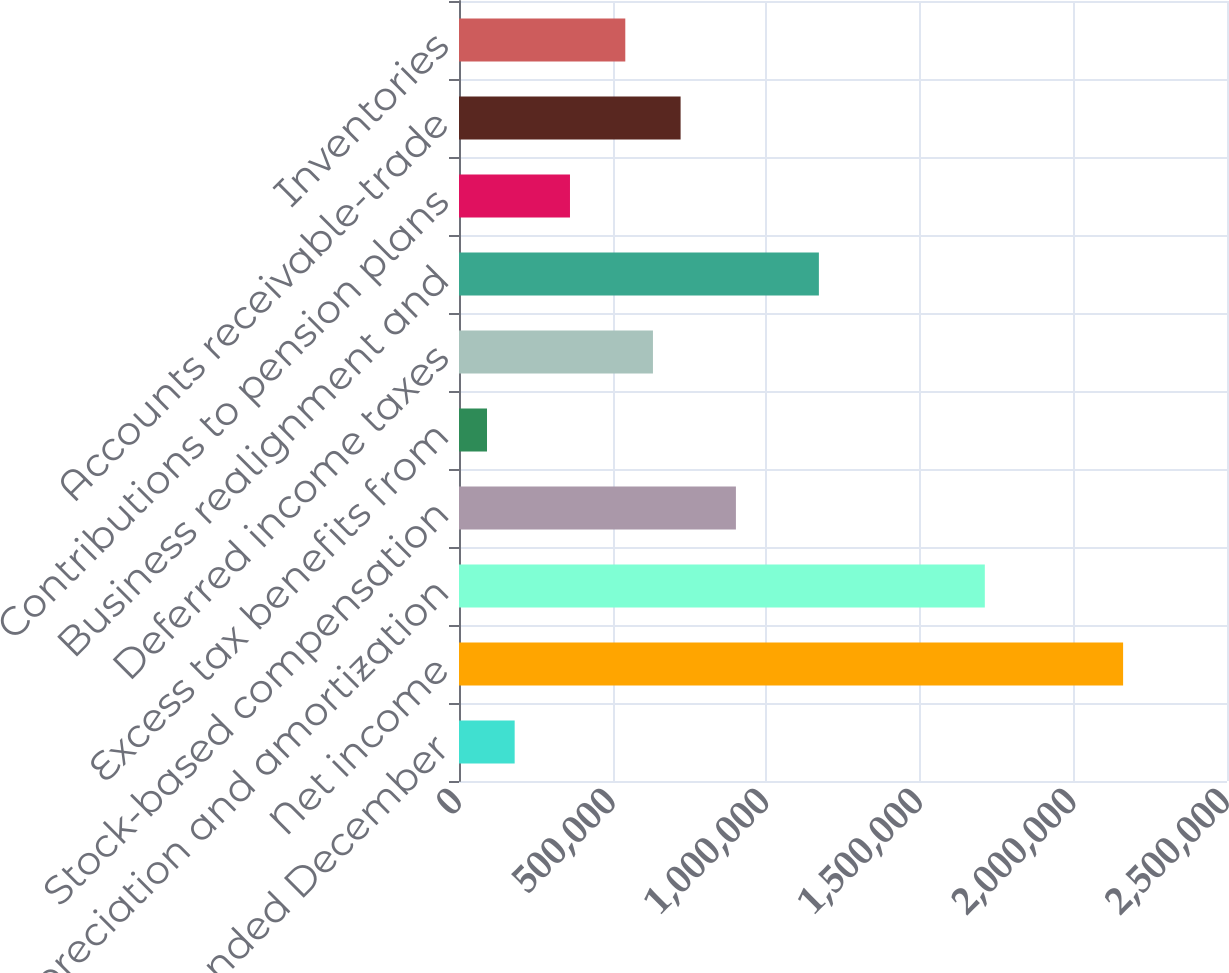Convert chart to OTSL. <chart><loc_0><loc_0><loc_500><loc_500><bar_chart><fcel>For the years ended December<fcel>Net income<fcel>Depreciation and amortization<fcel>Stock-based compensation<fcel>Excess tax benefits from<fcel>Deferred income taxes<fcel>Business realignment and<fcel>Contributions to pension plans<fcel>Accounts receivable-trade<fcel>Inventories<nl><fcel>181209<fcel>2.1618e+06<fcel>1.71166e+06<fcel>901423<fcel>91182.7<fcel>631343<fcel>1.1715e+06<fcel>361263<fcel>721370<fcel>541316<nl></chart> 